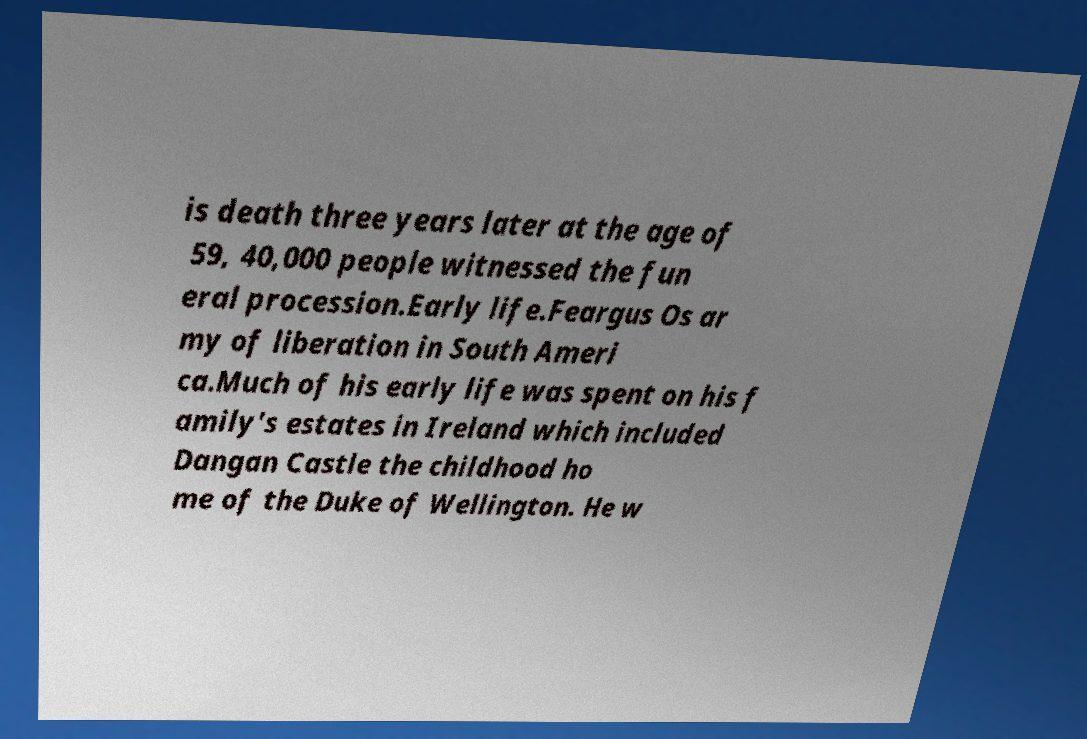Can you accurately transcribe the text from the provided image for me? is death three years later at the age of 59, 40,000 people witnessed the fun eral procession.Early life.Feargus Os ar my of liberation in South Ameri ca.Much of his early life was spent on his f amily's estates in Ireland which included Dangan Castle the childhood ho me of the Duke of Wellington. He w 